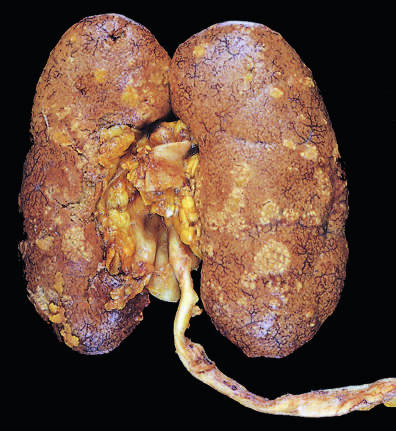s the cortical surface studded with focal pale abscesses, more numerous in the upper pole and middle region of the kidney?
Answer the question using a single word or phrase. Yes 